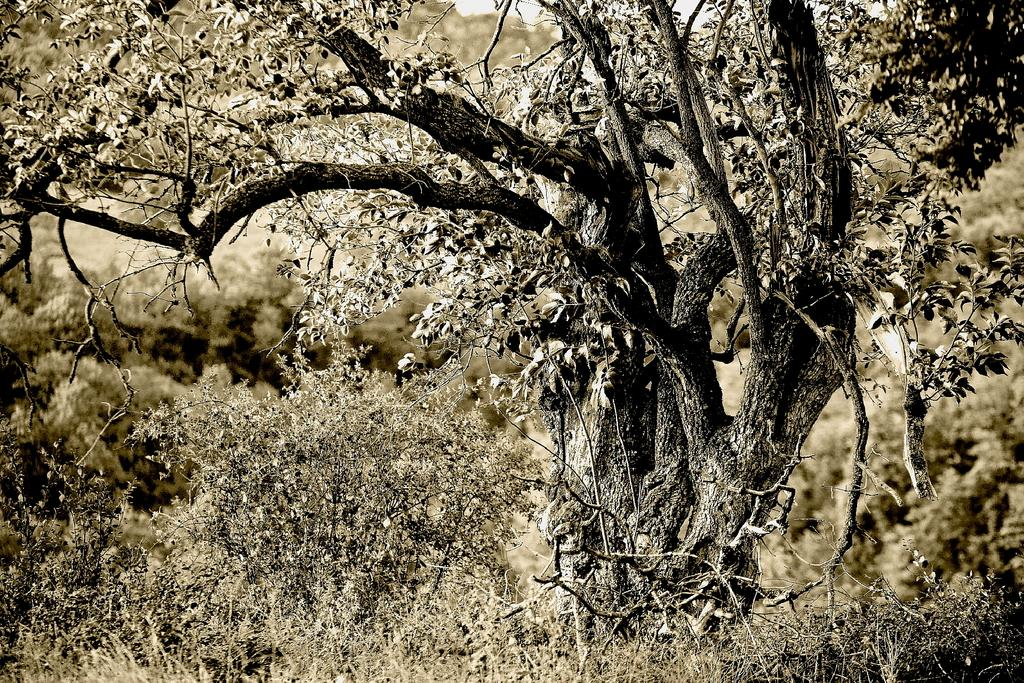What type of vegetation can be seen in the image? There are trees and plants in the image. Can you describe the overall appearance of the image? The image appears to be edited. What type of bell can be seen hanging from the trees in the image? There is no bell present in the image; it only features trees and plants. 